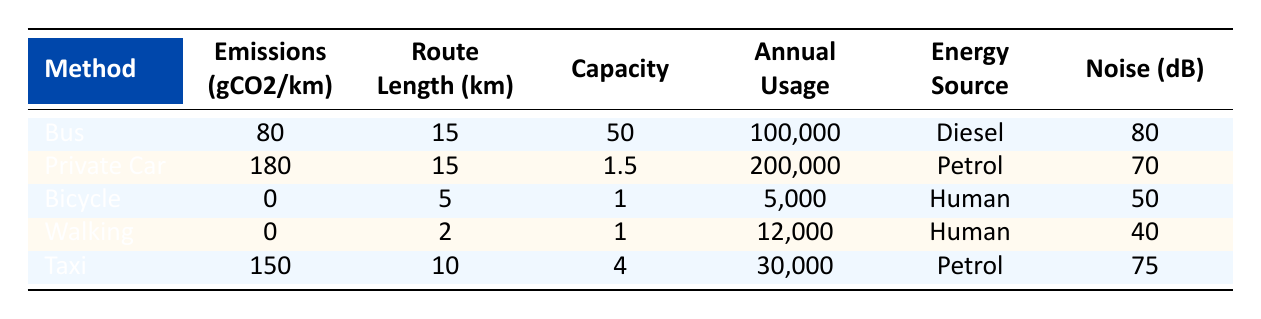What is the average emissions of a Bus (West Coast Motor Service) per kilometer? The emissions for the Bus (West Coast Motor Service) is listed as 80 gCO2/km in the table.
Answer: 80 gCO2/km How many passengers can a Private Car typically carry? The table indicates that a Private Car has a capacity of 1.5 passengers.
Answer: 1.5 passengers Which transportation method has the highest noise level? By comparing the noise levels in the table, the Bus has a noise level of 80 dB, which is higher than all other methods listed.
Answer: Bus What is the total annual usage of Private Cars in the table? The table states that there are 200,000 annual trips made by Private Cars, which represents the total usage.
Answer: 200,000 trips How much CO2 is emitted annually by Taxis over their route length? To find the annual CO2 emissions generated by Taxis, we can multiply the average emissions (150 gCO2/km) by the annual trips (30,000) and the route length (10 km): 150 * 30,000 * 10 = 45,000,000 gCO2.
Answer: 45,000,000 gCO2 What is the total emissions for all annual Taxis trips and Bus trips combined? To calculate the combined emissions, we find the Taxi emissions (45,000,000 gCO2 from the earlier calculation) and Bus emissions. For Buses: 80 gCO2/km * 100,000 passengers * 15 km = 120,000,000 gCO2. Summing both gives us: 45,000,000 + 120,000,000 = 165,000,000 gCO2.
Answer: 165,000,000 gCO2 Is it true that Bicycles do not emit any CO2 per kilometer? The table shows that the average emissions for Bicycles is listed as 0 gCO2/km, confirming that they do not emit CO2.
Answer: Yes Which method has the lowest noise level and what is that level? By checking the noise levels in the table, Walking has the lowest at 40 dB, making it the quietest method.
Answer: 40 dB What is the average number of passengers per trip for Taxis? The Taxi has a capacity of 4 passengers, so we consider that the average number of passengers per trip is typically around this figure, as it is designed to carry this many passengers.
Answer: 4 passengers How many more annual passengers does the Bus service have compared to the Taxi service? The Bus has 100,000 annual passengers while the Taxi has 30,000. The difference is 100,000 - 30,000 = 70,000.
Answer: 70,000 passengers 